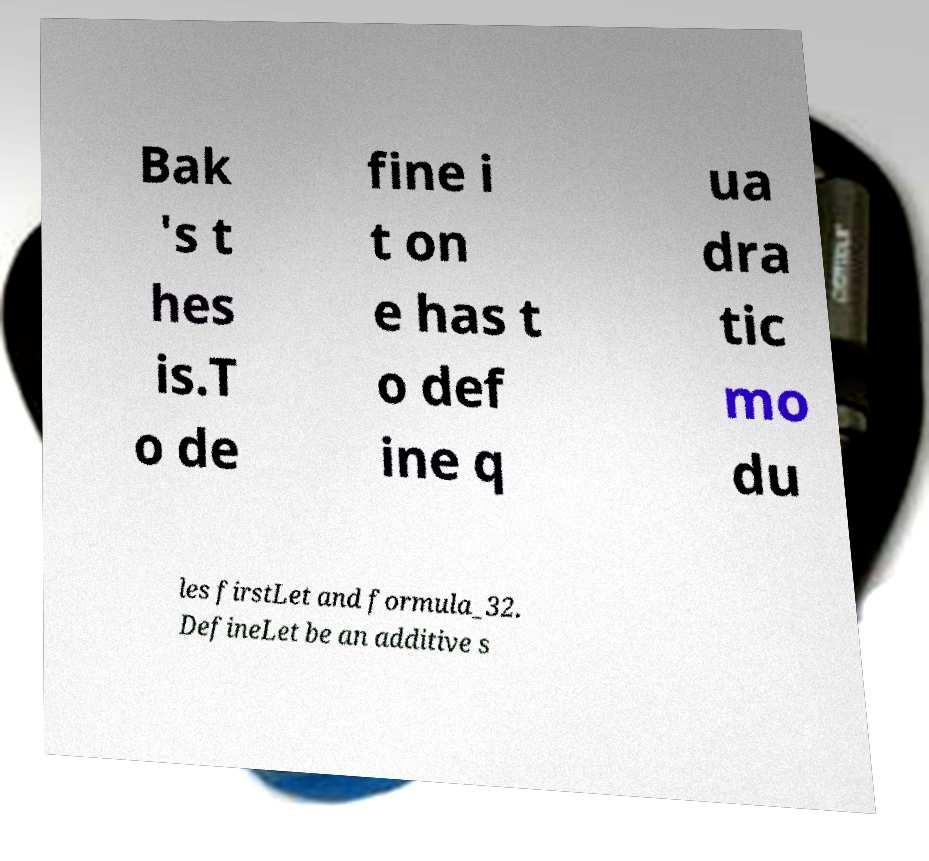What messages or text are displayed in this image? I need them in a readable, typed format. Bak 's t hes is.T o de fine i t on e has t o def ine q ua dra tic mo du les firstLet and formula_32. DefineLet be an additive s 